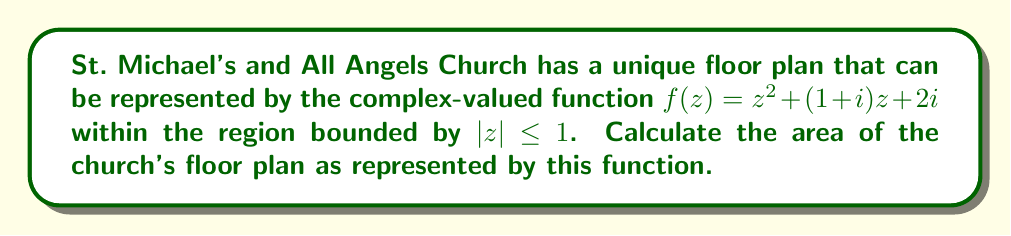Can you solve this math problem? To solve this problem, we need to use the area formula for complex-valued functions:

$$A = \iint_D |f'(z)|^2 dxdy$$

where $D$ is the domain of integration, in this case, the unit disk $|z| \leq 1$.

Steps:
1) First, we need to find $f'(z)$:
   $f'(z) = 2z + (1+i)$

2) Now, we calculate $|f'(z)|^2$:
   $|f'(z)|^2 = (2z + (1+i))(2\bar{z} + (1-i))$
              $= 4|z|^2 + 2(1-i)z + 2(1+i)\bar{z} + 2$
              $= 4(x^2+y^2) + 2(x-y) + 2(x+y) + 2$
              $= 4x^2 + 4y^2 + 4x + 2$

3) We need to integrate this over the unit disk. It's easier to use polar coordinates:
   $x = r\cos\theta$, $y = r\sin\theta$, $dxdy = rdrd\theta$
   
   The integral becomes:
   $$A = \int_0^{2\pi} \int_0^1 (4r^2 + 4r\cos\theta + 2)rdrd\theta$$

4) Integrate with respect to $r$:
   $$A = \int_0^{2\pi} [\frac{4r^4}{4} + \frac{4r^3\cos\theta}{3} + r^2]_0^1 d\theta$$
      $= \int_0^{2\pi} (1 + \frac{4}{3}\cos\theta + 1) d\theta$
      $= \int_0^{2\pi} (2 + \frac{4}{3}\cos\theta) d\theta$

5) Integrate with respect to $\theta$:
   $$A = [2\theta + \frac{4}{3}\sin\theta]_0^{2\pi}$$
      $= 4\pi + 0 = 4\pi$

Therefore, the area of the church's floor plan is $4\pi$ square units.
Answer: $4\pi$ square units 